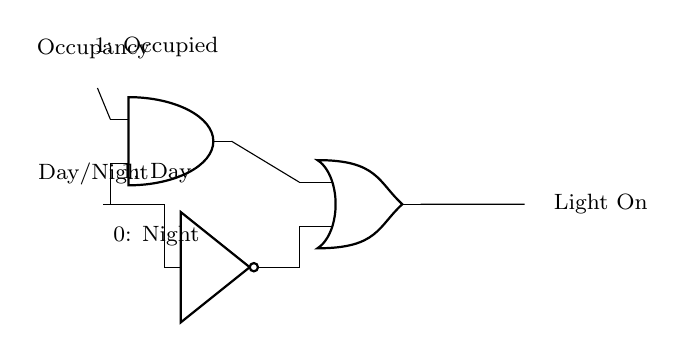What are the inputs to the circuit? The inputs are labeled as Occupancy and Day/Night, which indicate whether the room is occupied and whether it is daytime or nighttime, respectively.
Answer: Occupancy, Day/Night How many logic gates are used in the circuit? There are three logic gates present: one AND gate, one NOT gate, and one OR gate.
Answer: Three What is the output of the circuit? The output is labeled as Light On, representing whether the light will be illuminated based on the input conditions.
Answer: Light On What is the condition for the light to turn on? The light will turn on if the room is occupied (Occupancy is 1) and it is nighttime (Day/Night is 0), or if it is daytime (Day/Night is 1) regardless of occupancy.
Answer: Occupied and Night, or Day Explain how the NOT gate is used in this circuit. The NOT gate inverts the signal from the Day/Night input; when it is daytime (1), the NOT gate outputs 0, indicating nighttime, which then feeds into the OR gate to potentially turn on the light.
Answer: Inverts Day/Night What logical operation does the AND gate perform in this circuit? The AND gate performs a logical conjunction, outputting a 1 (true) only when both of its inputs are 1; in this case, it outputs true when there is occupancy and it is nighttime.
Answer: Logical conjunction 